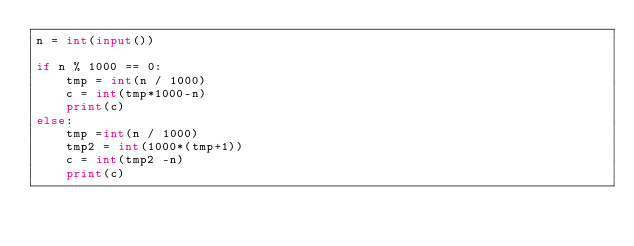Convert code to text. <code><loc_0><loc_0><loc_500><loc_500><_Python_>n = int(input())

if n % 1000 == 0:
    tmp = int(n / 1000)
    c = int(tmp*1000-n)
    print(c)
else:
    tmp =int(n / 1000)
    tmp2 = int(1000*(tmp+1))
    c = int(tmp2 -n)
    print(c)</code> 